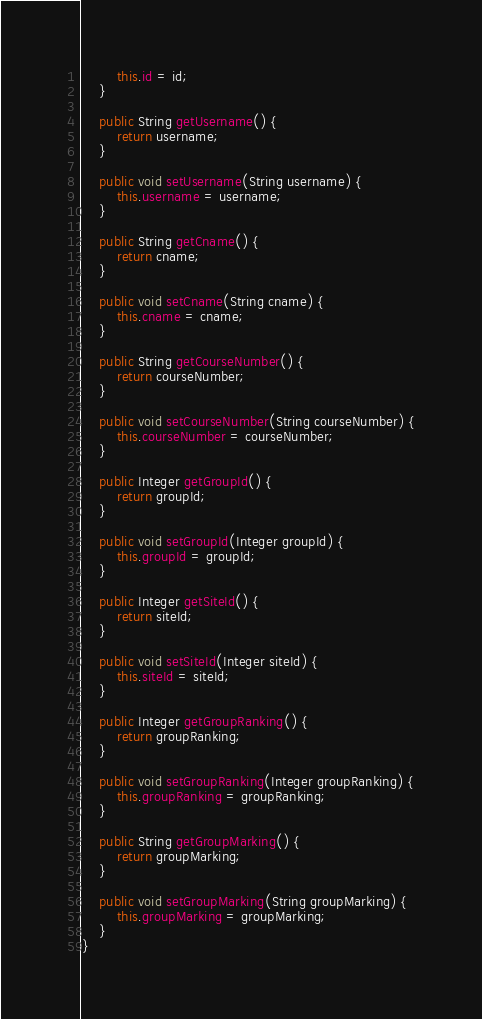Convert code to text. <code><loc_0><loc_0><loc_500><loc_500><_Java_>        this.id = id;
    }

    public String getUsername() {
        return username;
    }

    public void setUsername(String username) {
        this.username = username;
    }

    public String getCname() {
        return cname;
    }

    public void setCname(String cname) {
        this.cname = cname;
    }

    public String getCourseNumber() {
        return courseNumber;
    }

    public void setCourseNumber(String courseNumber) {
        this.courseNumber = courseNumber;
    }

    public Integer getGroupId() {
        return groupId;
    }

    public void setGroupId(Integer groupId) {
        this.groupId = groupId;
    }

    public Integer getSiteId() {
        return siteId;
    }

    public void setSiteId(Integer siteId) {
        this.siteId = siteId;
    }

    public Integer getGroupRanking() {
        return groupRanking;
    }

    public void setGroupRanking(Integer groupRanking) {
        this.groupRanking = groupRanking;
    }

    public String getGroupMarking() {
        return groupMarking;
    }

    public void setGroupMarking(String groupMarking) {
        this.groupMarking = groupMarking;
    }
}
</code> 